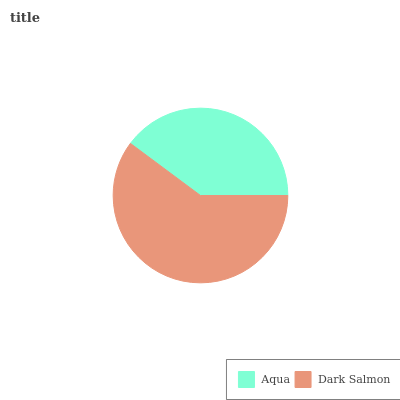Is Aqua the minimum?
Answer yes or no. Yes. Is Dark Salmon the maximum?
Answer yes or no. Yes. Is Dark Salmon the minimum?
Answer yes or no. No. Is Dark Salmon greater than Aqua?
Answer yes or no. Yes. Is Aqua less than Dark Salmon?
Answer yes or no. Yes. Is Aqua greater than Dark Salmon?
Answer yes or no. No. Is Dark Salmon less than Aqua?
Answer yes or no. No. Is Dark Salmon the high median?
Answer yes or no. Yes. Is Aqua the low median?
Answer yes or no. Yes. Is Aqua the high median?
Answer yes or no. No. Is Dark Salmon the low median?
Answer yes or no. No. 